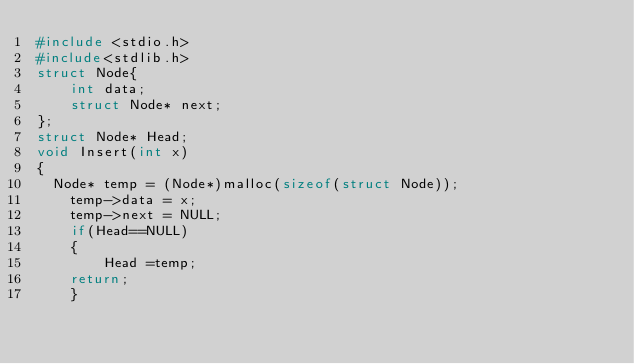<code> <loc_0><loc_0><loc_500><loc_500><_C++_>#include <stdio.h>
#include<stdlib.h>
struct Node{
    int data;
    struct Node* next;
};
struct Node* Head;
void Insert(int x)
{
  Node* temp = (Node*)malloc(sizeof(struct Node));
    temp->data = x;
    temp->next = NULL;
    if(Head==NULL)
    {
        Head =temp;
    return;    
    }</code> 